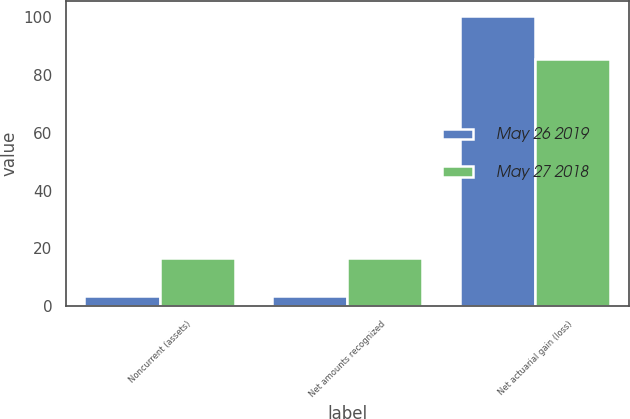<chart> <loc_0><loc_0><loc_500><loc_500><stacked_bar_chart><ecel><fcel>Noncurrent (assets)<fcel>Net amounts recognized<fcel>Net actuarial gain (loss)<nl><fcel>May 26 2019<fcel>3.5<fcel>3.5<fcel>100.4<nl><fcel>May 27 2018<fcel>16.6<fcel>16.6<fcel>85.4<nl></chart> 